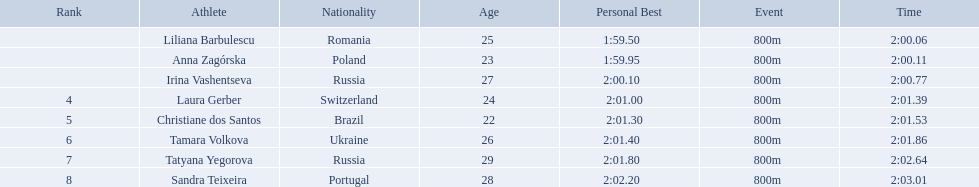Who are all of the athletes? Liliana Barbulescu, Anna Zagórska, Irina Vashentseva, Laura Gerber, Christiane dos Santos, Tamara Volkova, Tatyana Yegorova, Sandra Teixeira. What were their times in the heat? 2:00.06, 2:00.11, 2:00.77, 2:01.39, 2:01.53, 2:01.86, 2:02.64, 2:03.01. Of these, which is the top time? 2:00.06. Which athlete had this time? Liliana Barbulescu. Who were the athlete were in the athletics at the 2003 summer universiade - women's 800 metres? , Liliana Barbulescu, Anna Zagórska, Irina Vashentseva, Laura Gerber, Christiane dos Santos, Tamara Volkova, Tatyana Yegorova, Sandra Teixeira. What was anna zagorska finishing time? 2:00.11. Which athletes competed in the 2003 summer universiade - women's 800 metres? Liliana Barbulescu, Anna Zagórska, Irina Vashentseva, Laura Gerber, Christiane dos Santos, Tamara Volkova, Tatyana Yegorova, Sandra Teixeira. Of these, which are from poland? Anna Zagórska. What is her time? 2:00.11. Could you parse the entire table as a dict? {'header': ['Rank', 'Athlete', 'Nationality', 'Age', 'Personal Best', 'Event', 'Time'], 'rows': [['', 'Liliana Barbulescu', 'Romania', '25 ', '1:59.50     ', '800m ', '2:00.06'], ['', 'Anna Zagórska', 'Poland', '23 ', '1:59.95     ', '800m ', '2:00.11'], ['', 'Irina Vashentseva', 'Russia', '27 ', '2:00.10     ', '800m ', '2:00.77'], ['4', 'Laura Gerber', 'Switzerland', '24', '2:01.00   ', '800m ', '2:01.39'], ['5', 'Christiane dos Santos', 'Brazil', '22', '2:01.30   ', '800m ', '2:01.53'], ['6', 'Tamara Volkova', 'Ukraine', '26 ', '2:01.40     ', '800m ', '2:01.86'], ['7', 'Tatyana Yegorova', 'Russia', '29 ', '2:01.80     ', '800m ', '2:02.64'], ['8', 'Sandra Teixeira', 'Portugal', '28 ', '2:02.20     ', '800m ', '2:03.01']]} What were all the finishing times? 2:00.06, 2:00.11, 2:00.77, 2:01.39, 2:01.53, 2:01.86, 2:02.64, 2:03.01. Which of these is anna zagorska's? 2:00.11. 